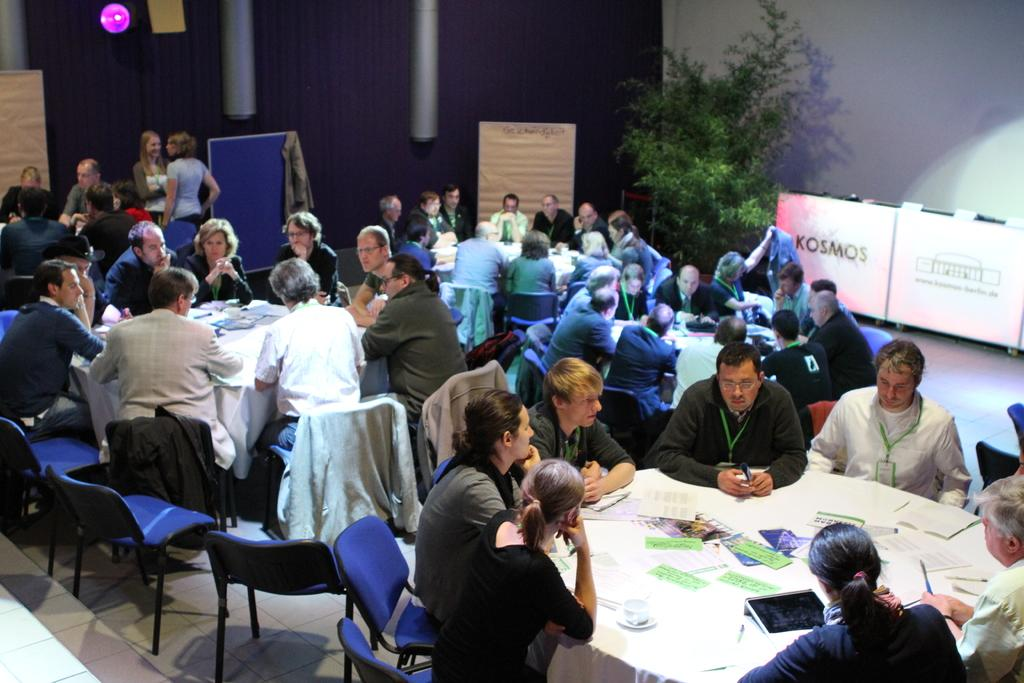What is: How many people are in the image? There is a group of people in the image. What are the people doing in the image? The people are sitting around a table. What color is the table in the image? The table is white. What can be seen on the table besides the people? There are papers on the table. How does the wire affect the people sitting around the table? There is no wire present in the image. 